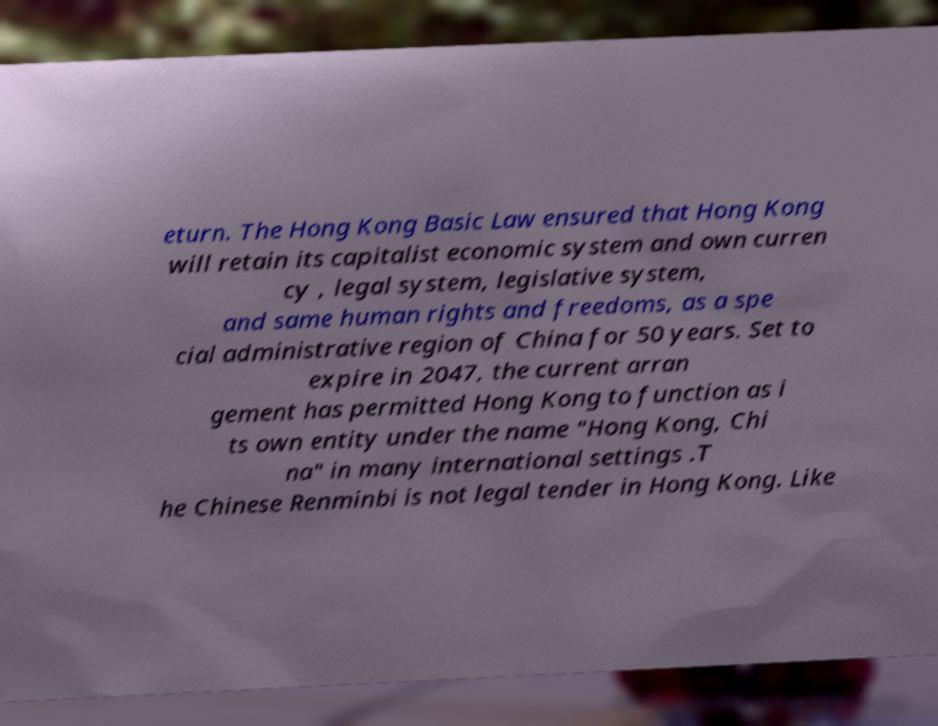Please read and relay the text visible in this image. What does it say? eturn. The Hong Kong Basic Law ensured that Hong Kong will retain its capitalist economic system and own curren cy , legal system, legislative system, and same human rights and freedoms, as a spe cial administrative region of China for 50 years. Set to expire in 2047, the current arran gement has permitted Hong Kong to function as i ts own entity under the name "Hong Kong, Chi na" in many international settings .T he Chinese Renminbi is not legal tender in Hong Kong. Like 